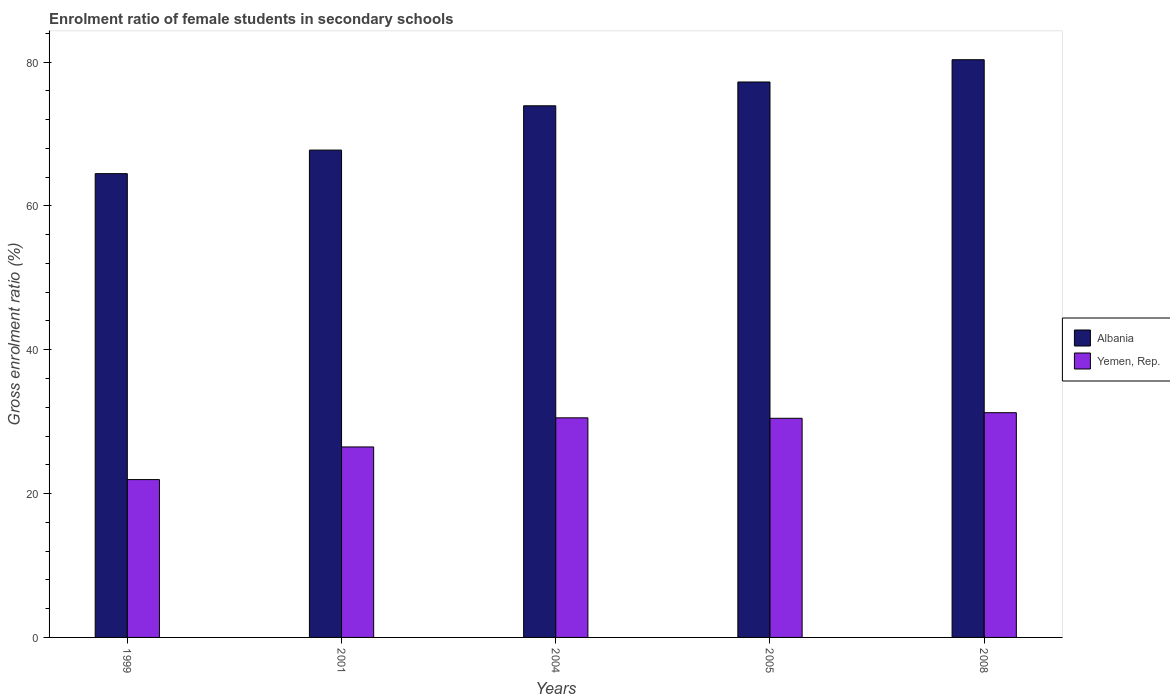Are the number of bars per tick equal to the number of legend labels?
Offer a very short reply. Yes. Are the number of bars on each tick of the X-axis equal?
Provide a succinct answer. Yes. How many bars are there on the 5th tick from the left?
Your response must be concise. 2. In how many cases, is the number of bars for a given year not equal to the number of legend labels?
Ensure brevity in your answer.  0. What is the enrolment ratio of female students in secondary schools in Yemen, Rep. in 2008?
Give a very brief answer. 31.25. Across all years, what is the maximum enrolment ratio of female students in secondary schools in Yemen, Rep.?
Ensure brevity in your answer.  31.25. Across all years, what is the minimum enrolment ratio of female students in secondary schools in Yemen, Rep.?
Provide a short and direct response. 21.95. In which year was the enrolment ratio of female students in secondary schools in Yemen, Rep. maximum?
Your response must be concise. 2008. In which year was the enrolment ratio of female students in secondary schools in Albania minimum?
Provide a succinct answer. 1999. What is the total enrolment ratio of female students in secondary schools in Yemen, Rep. in the graph?
Offer a very short reply. 140.69. What is the difference between the enrolment ratio of female students in secondary schools in Yemen, Rep. in 2004 and that in 2005?
Ensure brevity in your answer.  0.06. What is the difference between the enrolment ratio of female students in secondary schools in Yemen, Rep. in 2005 and the enrolment ratio of female students in secondary schools in Albania in 1999?
Keep it short and to the point. -34.02. What is the average enrolment ratio of female students in secondary schools in Yemen, Rep. per year?
Provide a short and direct response. 28.14. In the year 2008, what is the difference between the enrolment ratio of female students in secondary schools in Yemen, Rep. and enrolment ratio of female students in secondary schools in Albania?
Keep it short and to the point. -49.08. What is the ratio of the enrolment ratio of female students in secondary schools in Yemen, Rep. in 2001 to that in 2008?
Ensure brevity in your answer.  0.85. Is the enrolment ratio of female students in secondary schools in Yemen, Rep. in 2004 less than that in 2005?
Your answer should be compact. No. What is the difference between the highest and the second highest enrolment ratio of female students in secondary schools in Yemen, Rep.?
Provide a short and direct response. 0.72. What is the difference between the highest and the lowest enrolment ratio of female students in secondary schools in Albania?
Provide a short and direct response. 15.84. Is the sum of the enrolment ratio of female students in secondary schools in Albania in 1999 and 2001 greater than the maximum enrolment ratio of female students in secondary schools in Yemen, Rep. across all years?
Ensure brevity in your answer.  Yes. What does the 1st bar from the left in 2005 represents?
Your answer should be compact. Albania. What does the 1st bar from the right in 1999 represents?
Provide a succinct answer. Yemen, Rep. How many bars are there?
Provide a short and direct response. 10. Are all the bars in the graph horizontal?
Make the answer very short. No. How many years are there in the graph?
Your answer should be compact. 5. Does the graph contain any zero values?
Your answer should be very brief. No. Does the graph contain grids?
Provide a succinct answer. No. Where does the legend appear in the graph?
Make the answer very short. Center right. How many legend labels are there?
Offer a terse response. 2. What is the title of the graph?
Your answer should be compact. Enrolment ratio of female students in secondary schools. Does "Cyprus" appear as one of the legend labels in the graph?
Offer a very short reply. No. What is the label or title of the X-axis?
Make the answer very short. Years. What is the label or title of the Y-axis?
Make the answer very short. Gross enrolment ratio (%). What is the Gross enrolment ratio (%) in Albania in 1999?
Make the answer very short. 64.49. What is the Gross enrolment ratio (%) in Yemen, Rep. in 1999?
Your response must be concise. 21.95. What is the Gross enrolment ratio (%) in Albania in 2001?
Provide a short and direct response. 67.76. What is the Gross enrolment ratio (%) in Yemen, Rep. in 2001?
Provide a short and direct response. 26.48. What is the Gross enrolment ratio (%) of Albania in 2004?
Offer a very short reply. 73.92. What is the Gross enrolment ratio (%) in Yemen, Rep. in 2004?
Make the answer very short. 30.53. What is the Gross enrolment ratio (%) of Albania in 2005?
Your answer should be very brief. 77.23. What is the Gross enrolment ratio (%) of Yemen, Rep. in 2005?
Ensure brevity in your answer.  30.47. What is the Gross enrolment ratio (%) in Albania in 2008?
Make the answer very short. 80.33. What is the Gross enrolment ratio (%) in Yemen, Rep. in 2008?
Offer a very short reply. 31.25. Across all years, what is the maximum Gross enrolment ratio (%) in Albania?
Your answer should be very brief. 80.33. Across all years, what is the maximum Gross enrolment ratio (%) in Yemen, Rep.?
Ensure brevity in your answer.  31.25. Across all years, what is the minimum Gross enrolment ratio (%) in Albania?
Ensure brevity in your answer.  64.49. Across all years, what is the minimum Gross enrolment ratio (%) of Yemen, Rep.?
Your answer should be very brief. 21.95. What is the total Gross enrolment ratio (%) of Albania in the graph?
Your response must be concise. 363.73. What is the total Gross enrolment ratio (%) in Yemen, Rep. in the graph?
Keep it short and to the point. 140.69. What is the difference between the Gross enrolment ratio (%) of Albania in 1999 and that in 2001?
Give a very brief answer. -3.28. What is the difference between the Gross enrolment ratio (%) in Yemen, Rep. in 1999 and that in 2001?
Offer a very short reply. -4.54. What is the difference between the Gross enrolment ratio (%) in Albania in 1999 and that in 2004?
Give a very brief answer. -9.43. What is the difference between the Gross enrolment ratio (%) in Yemen, Rep. in 1999 and that in 2004?
Keep it short and to the point. -8.59. What is the difference between the Gross enrolment ratio (%) in Albania in 1999 and that in 2005?
Keep it short and to the point. -12.74. What is the difference between the Gross enrolment ratio (%) of Yemen, Rep. in 1999 and that in 2005?
Ensure brevity in your answer.  -8.52. What is the difference between the Gross enrolment ratio (%) of Albania in 1999 and that in 2008?
Ensure brevity in your answer.  -15.84. What is the difference between the Gross enrolment ratio (%) in Yemen, Rep. in 1999 and that in 2008?
Provide a succinct answer. -9.3. What is the difference between the Gross enrolment ratio (%) in Albania in 2001 and that in 2004?
Give a very brief answer. -6.16. What is the difference between the Gross enrolment ratio (%) of Yemen, Rep. in 2001 and that in 2004?
Your response must be concise. -4.05. What is the difference between the Gross enrolment ratio (%) in Albania in 2001 and that in 2005?
Give a very brief answer. -9.47. What is the difference between the Gross enrolment ratio (%) in Yemen, Rep. in 2001 and that in 2005?
Your answer should be compact. -3.99. What is the difference between the Gross enrolment ratio (%) of Albania in 2001 and that in 2008?
Make the answer very short. -12.57. What is the difference between the Gross enrolment ratio (%) in Yemen, Rep. in 2001 and that in 2008?
Offer a terse response. -4.76. What is the difference between the Gross enrolment ratio (%) in Albania in 2004 and that in 2005?
Provide a short and direct response. -3.31. What is the difference between the Gross enrolment ratio (%) of Yemen, Rep. in 2004 and that in 2005?
Ensure brevity in your answer.  0.06. What is the difference between the Gross enrolment ratio (%) of Albania in 2004 and that in 2008?
Offer a terse response. -6.41. What is the difference between the Gross enrolment ratio (%) of Yemen, Rep. in 2004 and that in 2008?
Provide a short and direct response. -0.72. What is the difference between the Gross enrolment ratio (%) in Albania in 2005 and that in 2008?
Provide a succinct answer. -3.1. What is the difference between the Gross enrolment ratio (%) of Yemen, Rep. in 2005 and that in 2008?
Provide a short and direct response. -0.78. What is the difference between the Gross enrolment ratio (%) of Albania in 1999 and the Gross enrolment ratio (%) of Yemen, Rep. in 2001?
Ensure brevity in your answer.  38. What is the difference between the Gross enrolment ratio (%) in Albania in 1999 and the Gross enrolment ratio (%) in Yemen, Rep. in 2004?
Give a very brief answer. 33.95. What is the difference between the Gross enrolment ratio (%) of Albania in 1999 and the Gross enrolment ratio (%) of Yemen, Rep. in 2005?
Offer a terse response. 34.02. What is the difference between the Gross enrolment ratio (%) in Albania in 1999 and the Gross enrolment ratio (%) in Yemen, Rep. in 2008?
Offer a very short reply. 33.24. What is the difference between the Gross enrolment ratio (%) of Albania in 2001 and the Gross enrolment ratio (%) of Yemen, Rep. in 2004?
Offer a very short reply. 37.23. What is the difference between the Gross enrolment ratio (%) in Albania in 2001 and the Gross enrolment ratio (%) in Yemen, Rep. in 2005?
Give a very brief answer. 37.29. What is the difference between the Gross enrolment ratio (%) in Albania in 2001 and the Gross enrolment ratio (%) in Yemen, Rep. in 2008?
Provide a succinct answer. 36.51. What is the difference between the Gross enrolment ratio (%) of Albania in 2004 and the Gross enrolment ratio (%) of Yemen, Rep. in 2005?
Offer a terse response. 43.45. What is the difference between the Gross enrolment ratio (%) of Albania in 2004 and the Gross enrolment ratio (%) of Yemen, Rep. in 2008?
Your answer should be compact. 42.67. What is the difference between the Gross enrolment ratio (%) in Albania in 2005 and the Gross enrolment ratio (%) in Yemen, Rep. in 2008?
Make the answer very short. 45.98. What is the average Gross enrolment ratio (%) of Albania per year?
Give a very brief answer. 72.75. What is the average Gross enrolment ratio (%) in Yemen, Rep. per year?
Give a very brief answer. 28.14. In the year 1999, what is the difference between the Gross enrolment ratio (%) of Albania and Gross enrolment ratio (%) of Yemen, Rep.?
Your response must be concise. 42.54. In the year 2001, what is the difference between the Gross enrolment ratio (%) of Albania and Gross enrolment ratio (%) of Yemen, Rep.?
Offer a terse response. 41.28. In the year 2004, what is the difference between the Gross enrolment ratio (%) of Albania and Gross enrolment ratio (%) of Yemen, Rep.?
Offer a terse response. 43.39. In the year 2005, what is the difference between the Gross enrolment ratio (%) in Albania and Gross enrolment ratio (%) in Yemen, Rep.?
Ensure brevity in your answer.  46.76. In the year 2008, what is the difference between the Gross enrolment ratio (%) of Albania and Gross enrolment ratio (%) of Yemen, Rep.?
Ensure brevity in your answer.  49.08. What is the ratio of the Gross enrolment ratio (%) of Albania in 1999 to that in 2001?
Provide a succinct answer. 0.95. What is the ratio of the Gross enrolment ratio (%) of Yemen, Rep. in 1999 to that in 2001?
Offer a very short reply. 0.83. What is the ratio of the Gross enrolment ratio (%) in Albania in 1999 to that in 2004?
Offer a terse response. 0.87. What is the ratio of the Gross enrolment ratio (%) in Yemen, Rep. in 1999 to that in 2004?
Your response must be concise. 0.72. What is the ratio of the Gross enrolment ratio (%) in Albania in 1999 to that in 2005?
Provide a succinct answer. 0.83. What is the ratio of the Gross enrolment ratio (%) of Yemen, Rep. in 1999 to that in 2005?
Make the answer very short. 0.72. What is the ratio of the Gross enrolment ratio (%) in Albania in 1999 to that in 2008?
Offer a very short reply. 0.8. What is the ratio of the Gross enrolment ratio (%) in Yemen, Rep. in 1999 to that in 2008?
Provide a short and direct response. 0.7. What is the ratio of the Gross enrolment ratio (%) of Albania in 2001 to that in 2004?
Provide a succinct answer. 0.92. What is the ratio of the Gross enrolment ratio (%) in Yemen, Rep. in 2001 to that in 2004?
Ensure brevity in your answer.  0.87. What is the ratio of the Gross enrolment ratio (%) in Albania in 2001 to that in 2005?
Make the answer very short. 0.88. What is the ratio of the Gross enrolment ratio (%) of Yemen, Rep. in 2001 to that in 2005?
Give a very brief answer. 0.87. What is the ratio of the Gross enrolment ratio (%) in Albania in 2001 to that in 2008?
Your answer should be very brief. 0.84. What is the ratio of the Gross enrolment ratio (%) of Yemen, Rep. in 2001 to that in 2008?
Your answer should be compact. 0.85. What is the ratio of the Gross enrolment ratio (%) of Albania in 2004 to that in 2005?
Provide a succinct answer. 0.96. What is the ratio of the Gross enrolment ratio (%) of Albania in 2004 to that in 2008?
Keep it short and to the point. 0.92. What is the ratio of the Gross enrolment ratio (%) in Yemen, Rep. in 2004 to that in 2008?
Your answer should be compact. 0.98. What is the ratio of the Gross enrolment ratio (%) in Albania in 2005 to that in 2008?
Make the answer very short. 0.96. What is the ratio of the Gross enrolment ratio (%) of Yemen, Rep. in 2005 to that in 2008?
Your answer should be very brief. 0.98. What is the difference between the highest and the second highest Gross enrolment ratio (%) of Albania?
Offer a very short reply. 3.1. What is the difference between the highest and the second highest Gross enrolment ratio (%) of Yemen, Rep.?
Keep it short and to the point. 0.72. What is the difference between the highest and the lowest Gross enrolment ratio (%) of Albania?
Your answer should be compact. 15.84. What is the difference between the highest and the lowest Gross enrolment ratio (%) in Yemen, Rep.?
Your answer should be very brief. 9.3. 